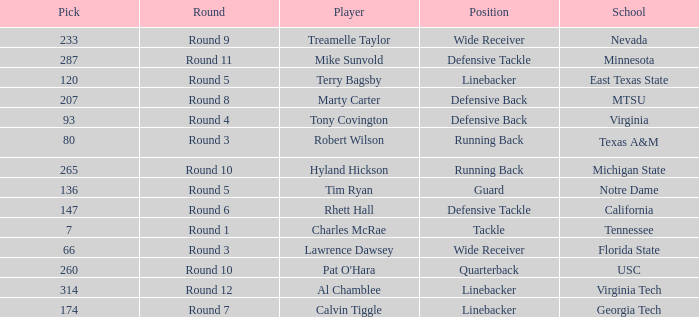What position did the player from East Texas State play? Linebacker. 